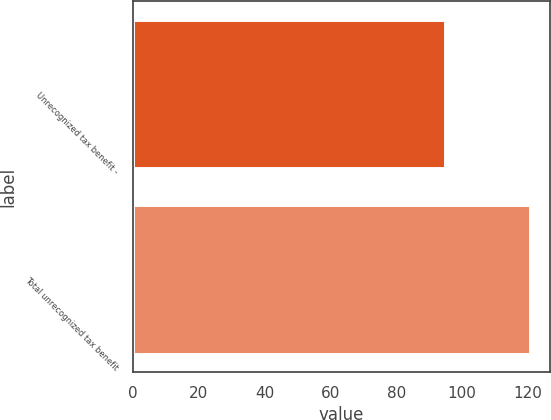Convert chart to OTSL. <chart><loc_0><loc_0><loc_500><loc_500><bar_chart><fcel>Unrecognized tax benefit -<fcel>Total unrecognized tax benefit<nl><fcel>94.9<fcel>120.7<nl></chart> 